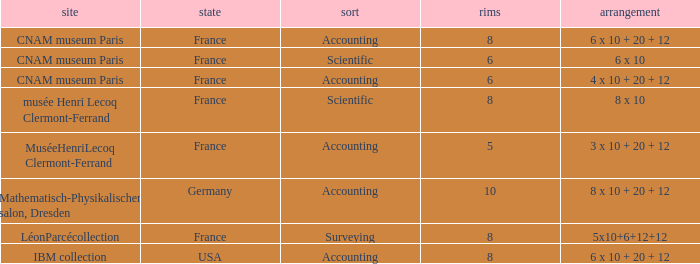What average wheels has accounting as the type, with IBM Collection as the location? 8.0. 